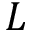Convert formula to latex. <formula><loc_0><loc_0><loc_500><loc_500>L</formula> 